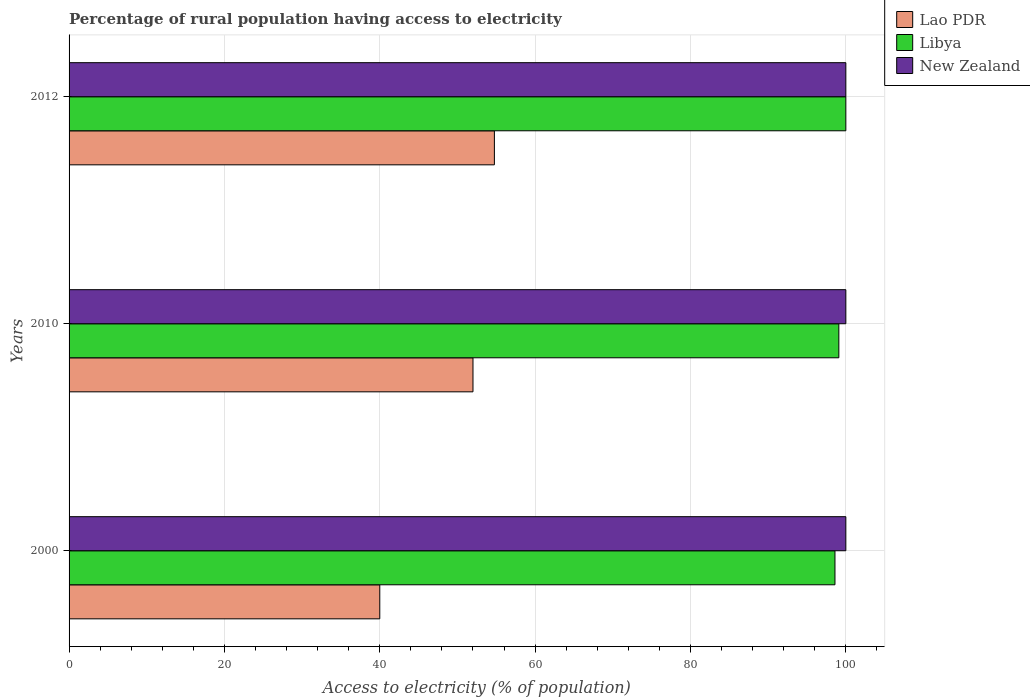How many groups of bars are there?
Your answer should be very brief. 3. Are the number of bars on each tick of the Y-axis equal?
Your answer should be very brief. Yes. In how many cases, is the number of bars for a given year not equal to the number of legend labels?
Your answer should be compact. 0. What is the percentage of rural population having access to electricity in New Zealand in 2000?
Your answer should be very brief. 100. Across all years, what is the maximum percentage of rural population having access to electricity in New Zealand?
Provide a succinct answer. 100. Across all years, what is the minimum percentage of rural population having access to electricity in Lao PDR?
Give a very brief answer. 40. In which year was the percentage of rural population having access to electricity in New Zealand maximum?
Keep it short and to the point. 2000. What is the total percentage of rural population having access to electricity in Lao PDR in the graph?
Your answer should be very brief. 146.75. What is the difference between the percentage of rural population having access to electricity in Libya in 2000 and the percentage of rural population having access to electricity in Lao PDR in 2012?
Offer a terse response. 43.85. What is the average percentage of rural population having access to electricity in Libya per year?
Give a very brief answer. 99.23. In the year 2000, what is the difference between the percentage of rural population having access to electricity in New Zealand and percentage of rural population having access to electricity in Libya?
Provide a succinct answer. 1.4. In how many years, is the percentage of rural population having access to electricity in New Zealand greater than 92 %?
Provide a succinct answer. 3. What is the ratio of the percentage of rural population having access to electricity in New Zealand in 2000 to that in 2010?
Your answer should be very brief. 1. Is the percentage of rural population having access to electricity in Lao PDR in 2000 less than that in 2012?
Provide a succinct answer. Yes. What is the difference between the highest and the second highest percentage of rural population having access to electricity in Libya?
Provide a short and direct response. 0.9. What is the difference between the highest and the lowest percentage of rural population having access to electricity in Lao PDR?
Ensure brevity in your answer.  14.75. Is the sum of the percentage of rural population having access to electricity in New Zealand in 2010 and 2012 greater than the maximum percentage of rural population having access to electricity in Libya across all years?
Offer a very short reply. Yes. What does the 1st bar from the top in 2012 represents?
Give a very brief answer. New Zealand. What does the 3rd bar from the bottom in 2000 represents?
Ensure brevity in your answer.  New Zealand. Is it the case that in every year, the sum of the percentage of rural population having access to electricity in Libya and percentage of rural population having access to electricity in New Zealand is greater than the percentage of rural population having access to electricity in Lao PDR?
Offer a terse response. Yes. Are all the bars in the graph horizontal?
Your answer should be compact. Yes. What is the difference between two consecutive major ticks on the X-axis?
Ensure brevity in your answer.  20. Does the graph contain any zero values?
Your answer should be compact. No. How many legend labels are there?
Give a very brief answer. 3. How are the legend labels stacked?
Your response must be concise. Vertical. What is the title of the graph?
Your response must be concise. Percentage of rural population having access to electricity. What is the label or title of the X-axis?
Your answer should be very brief. Access to electricity (% of population). What is the label or title of the Y-axis?
Ensure brevity in your answer.  Years. What is the Access to electricity (% of population) of Libya in 2000?
Ensure brevity in your answer.  98.6. What is the Access to electricity (% of population) in Libya in 2010?
Provide a short and direct response. 99.1. What is the Access to electricity (% of population) in Lao PDR in 2012?
Provide a short and direct response. 54.75. What is the Access to electricity (% of population) of Libya in 2012?
Offer a very short reply. 100. Across all years, what is the maximum Access to electricity (% of population) in Lao PDR?
Your answer should be compact. 54.75. Across all years, what is the maximum Access to electricity (% of population) of Libya?
Your answer should be compact. 100. Across all years, what is the maximum Access to electricity (% of population) of New Zealand?
Make the answer very short. 100. Across all years, what is the minimum Access to electricity (% of population) of Libya?
Keep it short and to the point. 98.6. Across all years, what is the minimum Access to electricity (% of population) of New Zealand?
Your response must be concise. 100. What is the total Access to electricity (% of population) of Lao PDR in the graph?
Your answer should be very brief. 146.75. What is the total Access to electricity (% of population) of Libya in the graph?
Your response must be concise. 297.7. What is the total Access to electricity (% of population) of New Zealand in the graph?
Provide a succinct answer. 300. What is the difference between the Access to electricity (% of population) of Lao PDR in 2000 and that in 2010?
Keep it short and to the point. -12. What is the difference between the Access to electricity (% of population) of Libya in 2000 and that in 2010?
Ensure brevity in your answer.  -0.5. What is the difference between the Access to electricity (% of population) in Lao PDR in 2000 and that in 2012?
Your response must be concise. -14.75. What is the difference between the Access to electricity (% of population) of Libya in 2000 and that in 2012?
Keep it short and to the point. -1.4. What is the difference between the Access to electricity (% of population) in Lao PDR in 2010 and that in 2012?
Make the answer very short. -2.75. What is the difference between the Access to electricity (% of population) of New Zealand in 2010 and that in 2012?
Keep it short and to the point. 0. What is the difference between the Access to electricity (% of population) in Lao PDR in 2000 and the Access to electricity (% of population) in Libya in 2010?
Your response must be concise. -59.1. What is the difference between the Access to electricity (% of population) in Lao PDR in 2000 and the Access to electricity (% of population) in New Zealand in 2010?
Offer a very short reply. -60. What is the difference between the Access to electricity (% of population) of Lao PDR in 2000 and the Access to electricity (% of population) of Libya in 2012?
Give a very brief answer. -60. What is the difference between the Access to electricity (% of population) of Lao PDR in 2000 and the Access to electricity (% of population) of New Zealand in 2012?
Your answer should be very brief. -60. What is the difference between the Access to electricity (% of population) of Lao PDR in 2010 and the Access to electricity (% of population) of Libya in 2012?
Make the answer very short. -48. What is the difference between the Access to electricity (% of population) in Lao PDR in 2010 and the Access to electricity (% of population) in New Zealand in 2012?
Keep it short and to the point. -48. What is the average Access to electricity (% of population) of Lao PDR per year?
Offer a very short reply. 48.92. What is the average Access to electricity (% of population) of Libya per year?
Offer a terse response. 99.23. In the year 2000, what is the difference between the Access to electricity (% of population) of Lao PDR and Access to electricity (% of population) of Libya?
Make the answer very short. -58.6. In the year 2000, what is the difference between the Access to electricity (% of population) of Lao PDR and Access to electricity (% of population) of New Zealand?
Your answer should be compact. -60. In the year 2000, what is the difference between the Access to electricity (% of population) of Libya and Access to electricity (% of population) of New Zealand?
Make the answer very short. -1.4. In the year 2010, what is the difference between the Access to electricity (% of population) in Lao PDR and Access to electricity (% of population) in Libya?
Your response must be concise. -47.1. In the year 2010, what is the difference between the Access to electricity (% of population) in Lao PDR and Access to electricity (% of population) in New Zealand?
Provide a short and direct response. -48. In the year 2010, what is the difference between the Access to electricity (% of population) in Libya and Access to electricity (% of population) in New Zealand?
Your answer should be very brief. -0.9. In the year 2012, what is the difference between the Access to electricity (% of population) of Lao PDR and Access to electricity (% of population) of Libya?
Make the answer very short. -45.25. In the year 2012, what is the difference between the Access to electricity (% of population) of Lao PDR and Access to electricity (% of population) of New Zealand?
Your response must be concise. -45.25. In the year 2012, what is the difference between the Access to electricity (% of population) of Libya and Access to electricity (% of population) of New Zealand?
Give a very brief answer. 0. What is the ratio of the Access to electricity (% of population) in Lao PDR in 2000 to that in 2010?
Make the answer very short. 0.77. What is the ratio of the Access to electricity (% of population) of Lao PDR in 2000 to that in 2012?
Provide a short and direct response. 0.73. What is the ratio of the Access to electricity (% of population) in New Zealand in 2000 to that in 2012?
Keep it short and to the point. 1. What is the ratio of the Access to electricity (% of population) in Lao PDR in 2010 to that in 2012?
Make the answer very short. 0.95. What is the difference between the highest and the second highest Access to electricity (% of population) of Lao PDR?
Give a very brief answer. 2.75. What is the difference between the highest and the second highest Access to electricity (% of population) in New Zealand?
Offer a very short reply. 0. What is the difference between the highest and the lowest Access to electricity (% of population) in Lao PDR?
Your response must be concise. 14.75. 